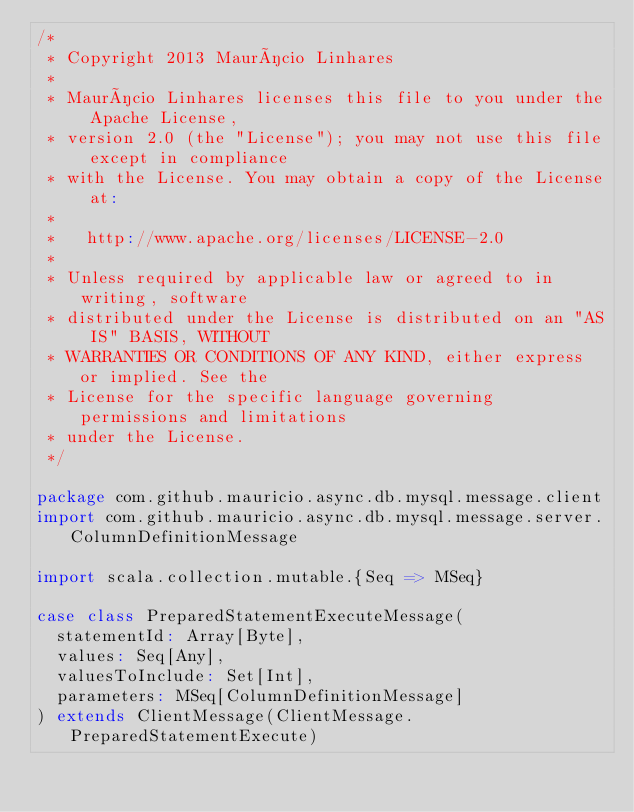Convert code to text. <code><loc_0><loc_0><loc_500><loc_500><_Scala_>/*
 * Copyright 2013 Maurício Linhares
 *
 * Maurício Linhares licenses this file to you under the Apache License,
 * version 2.0 (the "License"); you may not use this file except in compliance
 * with the License. You may obtain a copy of the License at:
 *
 *   http://www.apache.org/licenses/LICENSE-2.0
 *
 * Unless required by applicable law or agreed to in writing, software
 * distributed under the License is distributed on an "AS IS" BASIS, WITHOUT
 * WARRANTIES OR CONDITIONS OF ANY KIND, either express or implied. See the
 * License for the specific language governing permissions and limitations
 * under the License.
 */

package com.github.mauricio.async.db.mysql.message.client
import com.github.mauricio.async.db.mysql.message.server.ColumnDefinitionMessage

import scala.collection.mutable.{Seq => MSeq}

case class PreparedStatementExecuteMessage(
  statementId: Array[Byte],
  values: Seq[Any],
  valuesToInclude: Set[Int],
  parameters: MSeq[ColumnDefinitionMessage]
) extends ClientMessage(ClientMessage.PreparedStatementExecute)
</code> 